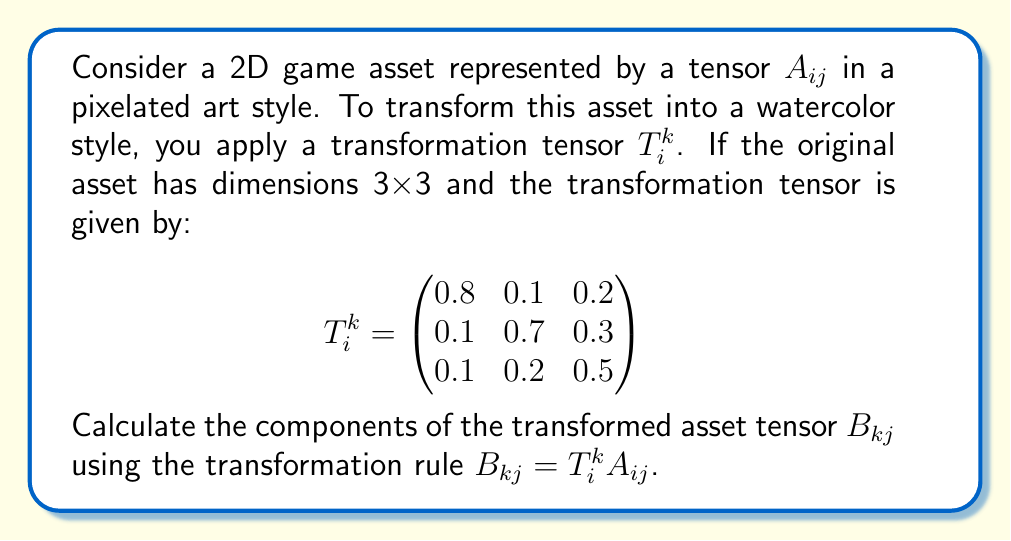Show me your answer to this math problem. To solve this problem, we need to apply the transformation rule for tensors:

$B_{kj} = T^k_i A_{ij}$

This is a contraction operation between the transformation tensor $T^k_i$ and the original asset tensor $A_{ij}$.

Step 1: Set up the equation
$$B_{kj} = \sum_{i=1}^3 T^k_i A_{ij}$$

Step 2: Calculate each component of $B_{kj}$
For $k = 1, 2, 3$ and $j = 1, 2, 3$:

$$B_{kj} = T^k_1 A_{1j} + T^k_2 A_{2j} + T^k_3 A_{3j}$$

Step 3: Express the result in matrix form
$$B_{kj} = \begin{pmatrix}
0.8 & 0.1 & 0.2 \\
0.1 & 0.7 & 0.3 \\
0.1 & 0.2 & 0.5
\end{pmatrix} \begin{pmatrix}
A_{11} & A_{12} & A_{13} \\
A_{21} & A_{22} & A_{23} \\
A_{31} & A_{32} & A_{33}
\end{pmatrix}$$

Step 4: Perform matrix multiplication
$$B_{kj} = \begin{pmatrix}
0.8A_{11} + 0.1A_{21} + 0.2A_{31} & 0.8A_{12} + 0.1A_{22} + 0.2A_{32} & 0.8A_{13} + 0.1A_{23} + 0.2A_{33} \\
0.1A_{11} + 0.7A_{21} + 0.3A_{31} & 0.1A_{12} + 0.7A_{22} + 0.3A_{32} & 0.1A_{13} + 0.7A_{23} + 0.3A_{33} \\
0.1A_{11} + 0.2A_{21} + 0.5A_{31} & 0.1A_{12} + 0.2A_{22} + 0.5A_{32} & 0.1A_{13} + 0.2A_{23} + 0.5A_{33}
\end{pmatrix}$$

This final matrix represents the components of the transformed asset tensor $B_{kj}$ in the watercolor style.
Answer: $B_{kj} = \begin{pmatrix}
0.8A_{11} + 0.1A_{21} + 0.2A_{31} & 0.8A_{12} + 0.1A_{22} + 0.2A_{32} & 0.8A_{13} + 0.1A_{23} + 0.2A_{33} \\
0.1A_{11} + 0.7A_{21} + 0.3A_{31} & 0.1A_{12} + 0.7A_{22} + 0.3A_{32} & 0.1A_{13} + 0.7A_{23} + 0.3A_{33} \\
0.1A_{11} + 0.2A_{21} + 0.5A_{31} & 0.1A_{12} + 0.2A_{22} + 0.5A_{32} & 0.1A_{13} + 0.2A_{23} + 0.5A_{33}
\end{pmatrix}$ 